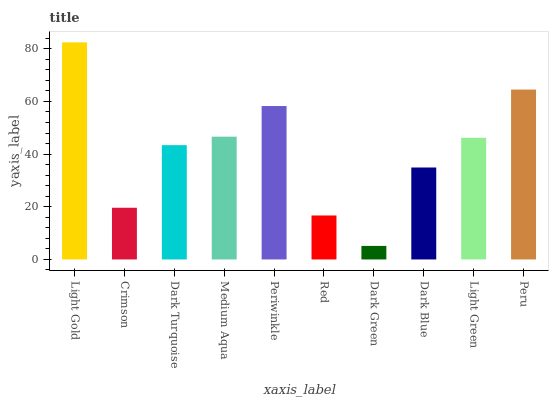Is Dark Green the minimum?
Answer yes or no. Yes. Is Light Gold the maximum?
Answer yes or no. Yes. Is Crimson the minimum?
Answer yes or no. No. Is Crimson the maximum?
Answer yes or no. No. Is Light Gold greater than Crimson?
Answer yes or no. Yes. Is Crimson less than Light Gold?
Answer yes or no. Yes. Is Crimson greater than Light Gold?
Answer yes or no. No. Is Light Gold less than Crimson?
Answer yes or no. No. Is Light Green the high median?
Answer yes or no. Yes. Is Dark Turquoise the low median?
Answer yes or no. Yes. Is Dark Turquoise the high median?
Answer yes or no. No. Is Dark Green the low median?
Answer yes or no. No. 